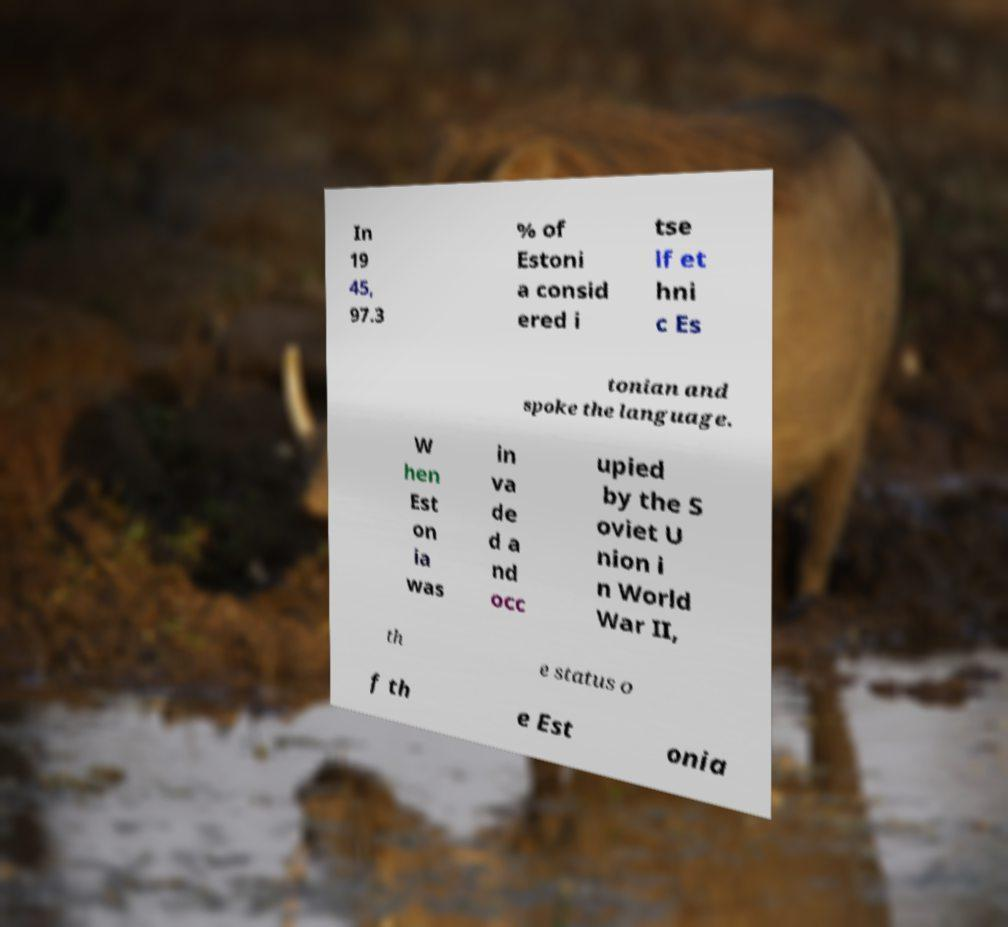Can you read and provide the text displayed in the image?This photo seems to have some interesting text. Can you extract and type it out for me? In 19 45, 97.3 % of Estoni a consid ered i tse lf et hni c Es tonian and spoke the language. W hen Est on ia was in va de d a nd occ upied by the S oviet U nion i n World War II, th e status o f th e Est onia 